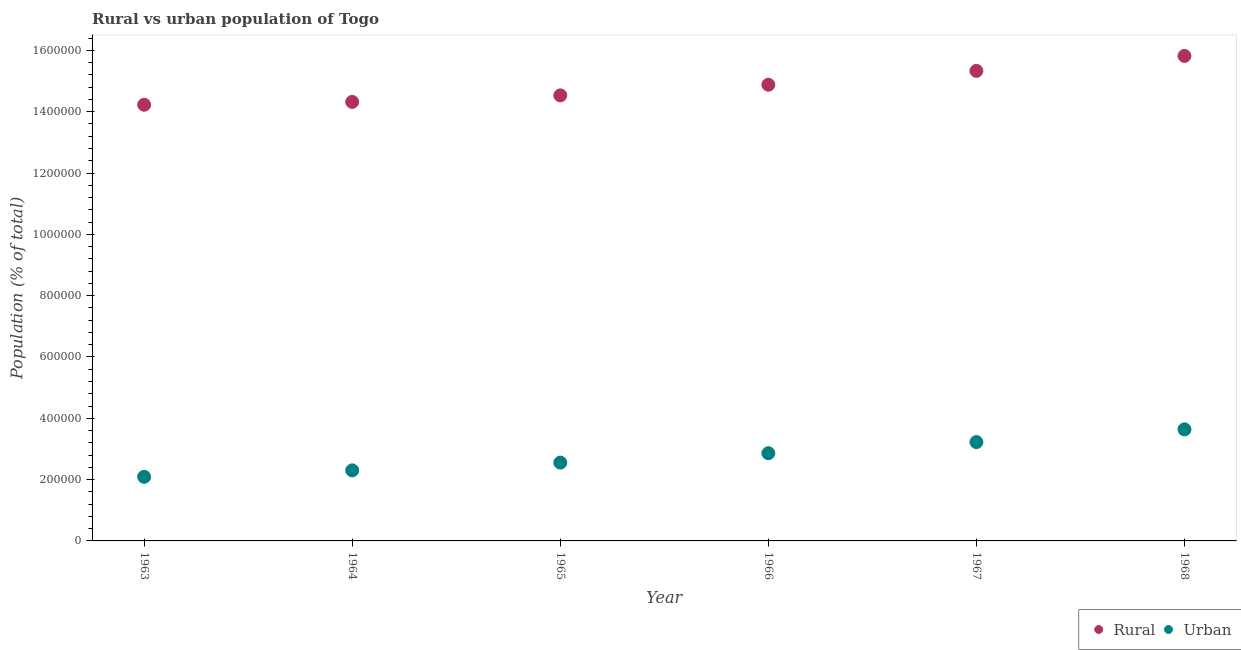Is the number of dotlines equal to the number of legend labels?
Offer a terse response. Yes. What is the rural population density in 1966?
Offer a terse response. 1.49e+06. Across all years, what is the maximum rural population density?
Make the answer very short. 1.58e+06. Across all years, what is the minimum urban population density?
Your answer should be compact. 2.09e+05. In which year was the urban population density maximum?
Keep it short and to the point. 1968. In which year was the rural population density minimum?
Your answer should be compact. 1963. What is the total urban population density in the graph?
Your response must be concise. 1.67e+06. What is the difference between the urban population density in 1965 and that in 1966?
Provide a succinct answer. -3.06e+04. What is the difference between the urban population density in 1963 and the rural population density in 1964?
Offer a terse response. -1.22e+06. What is the average rural population density per year?
Provide a short and direct response. 1.49e+06. In the year 1966, what is the difference between the urban population density and rural population density?
Ensure brevity in your answer.  -1.20e+06. What is the ratio of the urban population density in 1967 to that in 1968?
Provide a short and direct response. 0.89. Is the urban population density in 1963 less than that in 1965?
Your answer should be very brief. Yes. What is the difference between the highest and the second highest rural population density?
Offer a very short reply. 4.88e+04. What is the difference between the highest and the lowest urban population density?
Ensure brevity in your answer.  1.55e+05. In how many years, is the urban population density greater than the average urban population density taken over all years?
Keep it short and to the point. 3. Is the urban population density strictly greater than the rural population density over the years?
Keep it short and to the point. No. Is the rural population density strictly less than the urban population density over the years?
Offer a very short reply. No. What is the difference between two consecutive major ticks on the Y-axis?
Give a very brief answer. 2.00e+05. Does the graph contain grids?
Make the answer very short. No. Where does the legend appear in the graph?
Make the answer very short. Bottom right. What is the title of the graph?
Offer a very short reply. Rural vs urban population of Togo. What is the label or title of the X-axis?
Make the answer very short. Year. What is the label or title of the Y-axis?
Keep it short and to the point. Population (% of total). What is the Population (% of total) in Rural in 1963?
Keep it short and to the point. 1.42e+06. What is the Population (% of total) of Urban in 1963?
Give a very brief answer. 2.09e+05. What is the Population (% of total) of Rural in 1964?
Your response must be concise. 1.43e+06. What is the Population (% of total) of Urban in 1964?
Your answer should be compact. 2.30e+05. What is the Population (% of total) of Rural in 1965?
Your answer should be compact. 1.45e+06. What is the Population (% of total) in Urban in 1965?
Make the answer very short. 2.55e+05. What is the Population (% of total) of Rural in 1966?
Keep it short and to the point. 1.49e+06. What is the Population (% of total) in Urban in 1966?
Provide a short and direct response. 2.86e+05. What is the Population (% of total) in Rural in 1967?
Your answer should be very brief. 1.53e+06. What is the Population (% of total) of Urban in 1967?
Your answer should be very brief. 3.22e+05. What is the Population (% of total) of Rural in 1968?
Provide a succinct answer. 1.58e+06. What is the Population (% of total) of Urban in 1968?
Make the answer very short. 3.64e+05. Across all years, what is the maximum Population (% of total) of Rural?
Your answer should be very brief. 1.58e+06. Across all years, what is the maximum Population (% of total) in Urban?
Provide a short and direct response. 3.64e+05. Across all years, what is the minimum Population (% of total) of Rural?
Make the answer very short. 1.42e+06. Across all years, what is the minimum Population (% of total) in Urban?
Make the answer very short. 2.09e+05. What is the total Population (% of total) in Rural in the graph?
Make the answer very short. 8.91e+06. What is the total Population (% of total) of Urban in the graph?
Provide a short and direct response. 1.67e+06. What is the difference between the Population (% of total) in Rural in 1963 and that in 1964?
Make the answer very short. -9207. What is the difference between the Population (% of total) in Urban in 1963 and that in 1964?
Offer a very short reply. -2.11e+04. What is the difference between the Population (% of total) in Rural in 1963 and that in 1965?
Keep it short and to the point. -3.05e+04. What is the difference between the Population (% of total) of Urban in 1963 and that in 1965?
Provide a succinct answer. -4.64e+04. What is the difference between the Population (% of total) of Rural in 1963 and that in 1966?
Offer a very short reply. -6.52e+04. What is the difference between the Population (% of total) in Urban in 1963 and that in 1966?
Provide a succinct answer. -7.70e+04. What is the difference between the Population (% of total) in Rural in 1963 and that in 1967?
Provide a succinct answer. -1.10e+05. What is the difference between the Population (% of total) in Urban in 1963 and that in 1967?
Offer a terse response. -1.13e+05. What is the difference between the Population (% of total) in Rural in 1963 and that in 1968?
Provide a succinct answer. -1.59e+05. What is the difference between the Population (% of total) in Urban in 1963 and that in 1968?
Your response must be concise. -1.55e+05. What is the difference between the Population (% of total) in Rural in 1964 and that in 1965?
Make the answer very short. -2.13e+04. What is the difference between the Population (% of total) in Urban in 1964 and that in 1965?
Make the answer very short. -2.53e+04. What is the difference between the Population (% of total) of Rural in 1964 and that in 1966?
Provide a short and direct response. -5.60e+04. What is the difference between the Population (% of total) in Urban in 1964 and that in 1966?
Offer a terse response. -5.59e+04. What is the difference between the Population (% of total) in Rural in 1964 and that in 1967?
Give a very brief answer. -1.01e+05. What is the difference between the Population (% of total) of Urban in 1964 and that in 1967?
Your answer should be very brief. -9.22e+04. What is the difference between the Population (% of total) in Rural in 1964 and that in 1968?
Your answer should be compact. -1.50e+05. What is the difference between the Population (% of total) in Urban in 1964 and that in 1968?
Keep it short and to the point. -1.34e+05. What is the difference between the Population (% of total) in Rural in 1965 and that in 1966?
Your response must be concise. -3.48e+04. What is the difference between the Population (% of total) of Urban in 1965 and that in 1966?
Provide a short and direct response. -3.06e+04. What is the difference between the Population (% of total) of Rural in 1965 and that in 1967?
Offer a terse response. -7.99e+04. What is the difference between the Population (% of total) of Urban in 1965 and that in 1967?
Provide a short and direct response. -6.69e+04. What is the difference between the Population (% of total) of Rural in 1965 and that in 1968?
Your answer should be compact. -1.29e+05. What is the difference between the Population (% of total) in Urban in 1965 and that in 1968?
Your response must be concise. -1.08e+05. What is the difference between the Population (% of total) in Rural in 1966 and that in 1967?
Provide a short and direct response. -4.51e+04. What is the difference between the Population (% of total) in Urban in 1966 and that in 1967?
Provide a succinct answer. -3.63e+04. What is the difference between the Population (% of total) of Rural in 1966 and that in 1968?
Offer a terse response. -9.40e+04. What is the difference between the Population (% of total) in Urban in 1966 and that in 1968?
Offer a terse response. -7.78e+04. What is the difference between the Population (% of total) of Rural in 1967 and that in 1968?
Offer a very short reply. -4.88e+04. What is the difference between the Population (% of total) in Urban in 1967 and that in 1968?
Your answer should be very brief. -4.15e+04. What is the difference between the Population (% of total) of Rural in 1963 and the Population (% of total) of Urban in 1964?
Provide a short and direct response. 1.19e+06. What is the difference between the Population (% of total) of Rural in 1963 and the Population (% of total) of Urban in 1965?
Provide a succinct answer. 1.17e+06. What is the difference between the Population (% of total) of Rural in 1963 and the Population (% of total) of Urban in 1966?
Your answer should be very brief. 1.14e+06. What is the difference between the Population (% of total) of Rural in 1963 and the Population (% of total) of Urban in 1967?
Offer a terse response. 1.10e+06. What is the difference between the Population (% of total) of Rural in 1963 and the Population (% of total) of Urban in 1968?
Offer a terse response. 1.06e+06. What is the difference between the Population (% of total) in Rural in 1964 and the Population (% of total) in Urban in 1965?
Provide a succinct answer. 1.18e+06. What is the difference between the Population (% of total) in Rural in 1964 and the Population (% of total) in Urban in 1966?
Provide a short and direct response. 1.15e+06. What is the difference between the Population (% of total) of Rural in 1964 and the Population (% of total) of Urban in 1967?
Give a very brief answer. 1.11e+06. What is the difference between the Population (% of total) in Rural in 1964 and the Population (% of total) in Urban in 1968?
Offer a terse response. 1.07e+06. What is the difference between the Population (% of total) of Rural in 1965 and the Population (% of total) of Urban in 1966?
Keep it short and to the point. 1.17e+06. What is the difference between the Population (% of total) of Rural in 1965 and the Population (% of total) of Urban in 1967?
Give a very brief answer. 1.13e+06. What is the difference between the Population (% of total) of Rural in 1965 and the Population (% of total) of Urban in 1968?
Make the answer very short. 1.09e+06. What is the difference between the Population (% of total) in Rural in 1966 and the Population (% of total) in Urban in 1967?
Give a very brief answer. 1.17e+06. What is the difference between the Population (% of total) of Rural in 1966 and the Population (% of total) of Urban in 1968?
Keep it short and to the point. 1.12e+06. What is the difference between the Population (% of total) of Rural in 1967 and the Population (% of total) of Urban in 1968?
Provide a succinct answer. 1.17e+06. What is the average Population (% of total) in Rural per year?
Offer a very short reply. 1.49e+06. What is the average Population (% of total) of Urban per year?
Keep it short and to the point. 2.78e+05. In the year 1963, what is the difference between the Population (% of total) of Rural and Population (% of total) of Urban?
Offer a very short reply. 1.21e+06. In the year 1964, what is the difference between the Population (% of total) of Rural and Population (% of total) of Urban?
Keep it short and to the point. 1.20e+06. In the year 1965, what is the difference between the Population (% of total) in Rural and Population (% of total) in Urban?
Keep it short and to the point. 1.20e+06. In the year 1966, what is the difference between the Population (% of total) of Rural and Population (% of total) of Urban?
Provide a succinct answer. 1.20e+06. In the year 1967, what is the difference between the Population (% of total) of Rural and Population (% of total) of Urban?
Keep it short and to the point. 1.21e+06. In the year 1968, what is the difference between the Population (% of total) of Rural and Population (% of total) of Urban?
Provide a succinct answer. 1.22e+06. What is the ratio of the Population (% of total) in Urban in 1963 to that in 1964?
Ensure brevity in your answer.  0.91. What is the ratio of the Population (% of total) in Rural in 1963 to that in 1965?
Keep it short and to the point. 0.98. What is the ratio of the Population (% of total) in Urban in 1963 to that in 1965?
Offer a very short reply. 0.82. What is the ratio of the Population (% of total) of Rural in 1963 to that in 1966?
Your answer should be very brief. 0.96. What is the ratio of the Population (% of total) of Urban in 1963 to that in 1966?
Provide a short and direct response. 0.73. What is the ratio of the Population (% of total) in Rural in 1963 to that in 1967?
Your response must be concise. 0.93. What is the ratio of the Population (% of total) in Urban in 1963 to that in 1967?
Give a very brief answer. 0.65. What is the ratio of the Population (% of total) in Rural in 1963 to that in 1968?
Your answer should be compact. 0.9. What is the ratio of the Population (% of total) in Urban in 1963 to that in 1968?
Make the answer very short. 0.57. What is the ratio of the Population (% of total) in Rural in 1964 to that in 1965?
Ensure brevity in your answer.  0.99. What is the ratio of the Population (% of total) of Urban in 1964 to that in 1965?
Your answer should be very brief. 0.9. What is the ratio of the Population (% of total) of Rural in 1964 to that in 1966?
Offer a terse response. 0.96. What is the ratio of the Population (% of total) in Urban in 1964 to that in 1966?
Provide a short and direct response. 0.8. What is the ratio of the Population (% of total) in Rural in 1964 to that in 1967?
Give a very brief answer. 0.93. What is the ratio of the Population (% of total) in Urban in 1964 to that in 1967?
Offer a terse response. 0.71. What is the ratio of the Population (% of total) of Rural in 1964 to that in 1968?
Your answer should be very brief. 0.91. What is the ratio of the Population (% of total) in Urban in 1964 to that in 1968?
Provide a short and direct response. 0.63. What is the ratio of the Population (% of total) of Rural in 1965 to that in 1966?
Keep it short and to the point. 0.98. What is the ratio of the Population (% of total) in Urban in 1965 to that in 1966?
Offer a very short reply. 0.89. What is the ratio of the Population (% of total) of Rural in 1965 to that in 1967?
Offer a terse response. 0.95. What is the ratio of the Population (% of total) of Urban in 1965 to that in 1967?
Offer a terse response. 0.79. What is the ratio of the Population (% of total) in Rural in 1965 to that in 1968?
Offer a very short reply. 0.92. What is the ratio of the Population (% of total) in Urban in 1965 to that in 1968?
Your answer should be very brief. 0.7. What is the ratio of the Population (% of total) of Rural in 1966 to that in 1967?
Offer a very short reply. 0.97. What is the ratio of the Population (% of total) in Urban in 1966 to that in 1967?
Offer a very short reply. 0.89. What is the ratio of the Population (% of total) of Rural in 1966 to that in 1968?
Give a very brief answer. 0.94. What is the ratio of the Population (% of total) of Urban in 1966 to that in 1968?
Offer a terse response. 0.79. What is the ratio of the Population (% of total) of Rural in 1967 to that in 1968?
Provide a succinct answer. 0.97. What is the ratio of the Population (% of total) in Urban in 1967 to that in 1968?
Provide a short and direct response. 0.89. What is the difference between the highest and the second highest Population (% of total) of Rural?
Your answer should be compact. 4.88e+04. What is the difference between the highest and the second highest Population (% of total) of Urban?
Your answer should be very brief. 4.15e+04. What is the difference between the highest and the lowest Population (% of total) in Rural?
Provide a succinct answer. 1.59e+05. What is the difference between the highest and the lowest Population (% of total) in Urban?
Make the answer very short. 1.55e+05. 